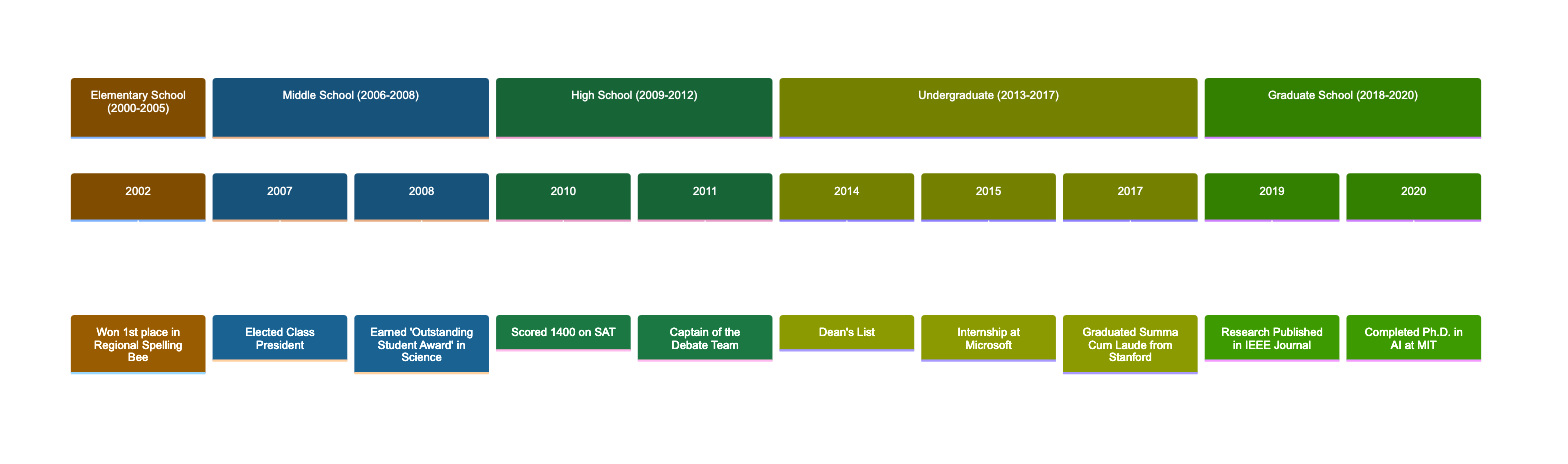What is the first award Chris received? The timeline indicates that the first award Chris received was in 2002, when he won 1st place in the Regional Spelling Bee during Elementary School.
Answer: 1st place in Regional Spelling Bee In what year did Chris earn the 'Outstanding Student Award' in Science? The timeline specifies that Chris earned the 'Outstanding Student Award' in Science in 2008 during Middle School.
Answer: 2008 How many leadership roles did Chris have in Middle and High School combined? From the timeline, Chris had one leadership role as Class President in Middle School (2007) and one as Captain of the Debate Team in High School (2011), giving a total of two leadership roles combined.
Answer: 2 What significant exam did Chris take during High School? According to the timeline, the significant exam Chris took during High School was the SAT, in which he scored 1400 in 2010.
Answer: SAT Which university did Chris graduate from in 2017? The timeline shows that Chris graduated from Stanford University in 2017, where he achieved the honor of Summa Cum Laude with a degree in Computer Science.
Answer: Stanford University What was the final achievement listed in Chris's academic journey? The last achievement noted on the timeline is on the one for Graduate School in 2020, where Chris completed his Ph.D. in Artificial Intelligence at MIT.
Answer: Completed Ph.D. in AI at MIT In what year did Chris publish research in an IEEE Journal? The timeline states that Chris published research in the IEEE Journal in 2019 during his Graduate School period.
Answer: 2019 What is the total number of key milestones Chris achieved throughout his academic journey? By reviewing the timeline, there are eight key milestones listed across the various stages of Chris's academic journey: one in Elementary (1), two in Middle School (2), two in High School (2), three in Undergraduate (3), and two in Graduate School (2), totaling eight.
Answer: 8 What award did Chris receive during his Undergraduate studies? According to the timeline, Chris received the Dean's List award in 2014 during his Undergraduate studies.
Answer: Dean's List 